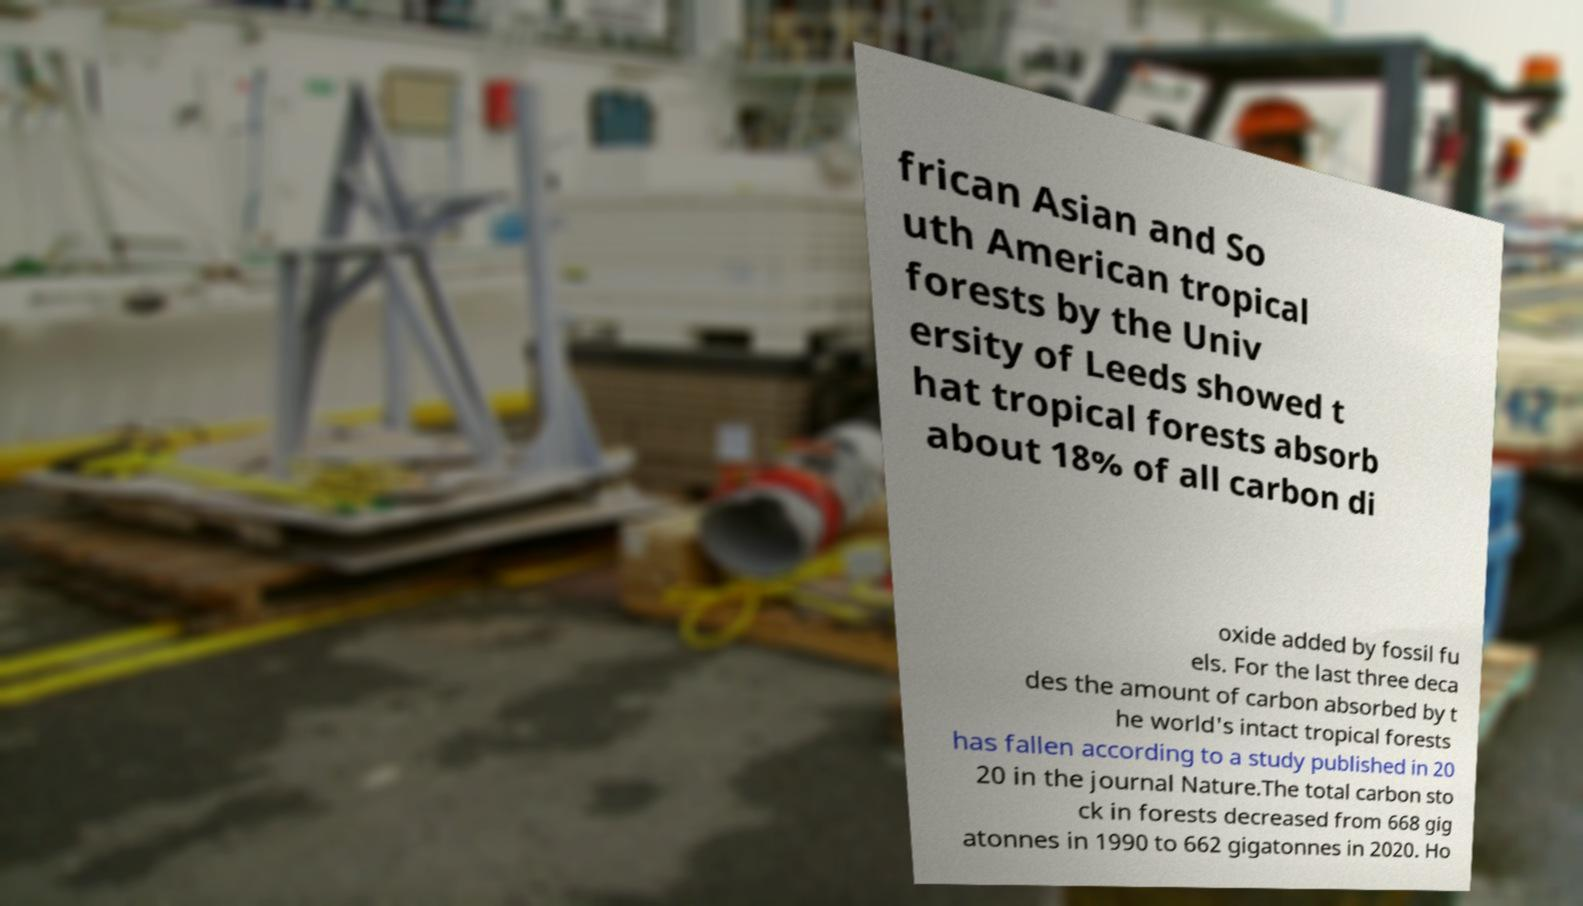Can you accurately transcribe the text from the provided image for me? frican Asian and So uth American tropical forests by the Univ ersity of Leeds showed t hat tropical forests absorb about 18% of all carbon di oxide added by fossil fu els. For the last three deca des the amount of carbon absorbed by t he world's intact tropical forests has fallen according to a study published in 20 20 in the journal Nature.The total carbon sto ck in forests decreased from 668 gig atonnes in 1990 to 662 gigatonnes in 2020. Ho 